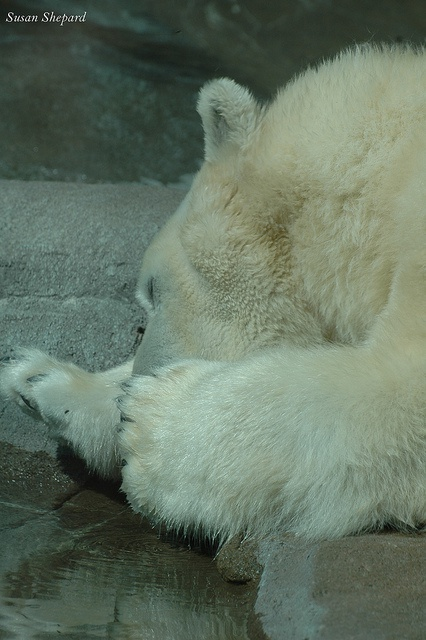Describe the objects in this image and their specific colors. I can see a bear in black, darkgray, and gray tones in this image. 